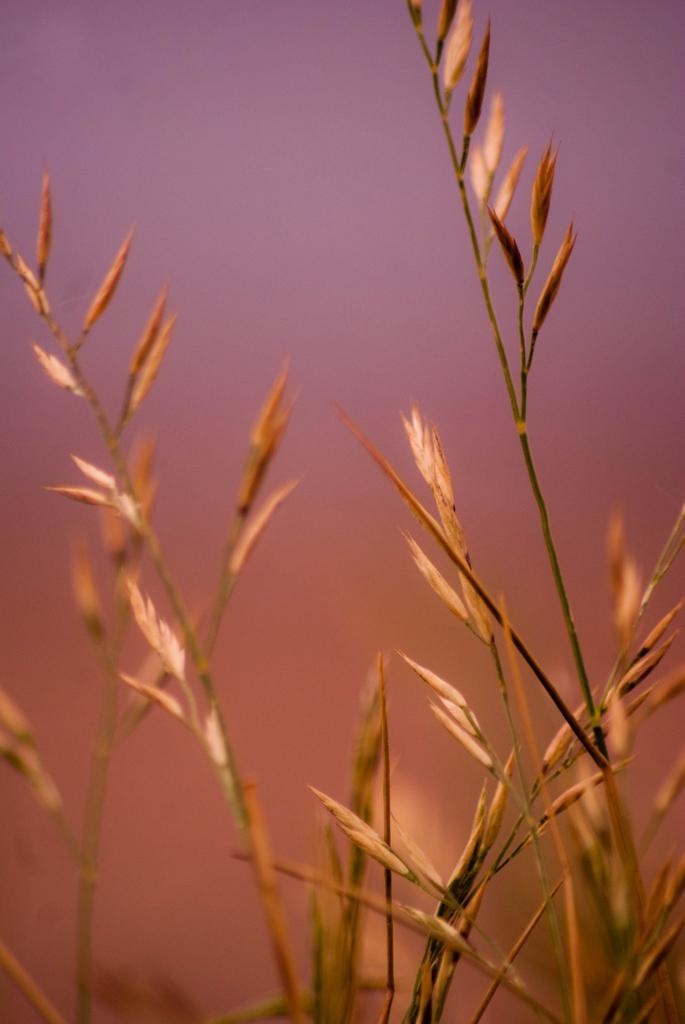Could you give a brief overview of what you see in this image? In this image there are plants towards the bottom of the image, at the background of the image there is the sky. 